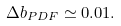Convert formula to latex. <formula><loc_0><loc_0><loc_500><loc_500>\Delta b _ { P D F } \simeq 0 . 0 1 .</formula> 